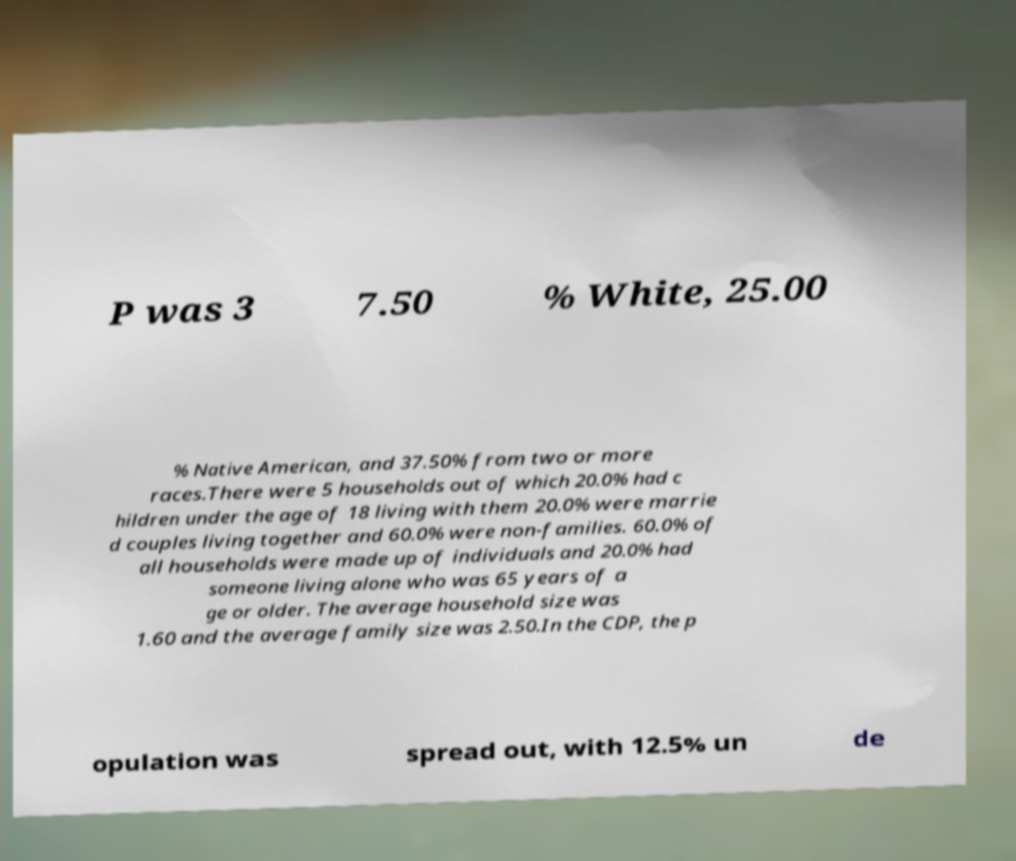Can you read and provide the text displayed in the image?This photo seems to have some interesting text. Can you extract and type it out for me? P was 3 7.50 % White, 25.00 % Native American, and 37.50% from two or more races.There were 5 households out of which 20.0% had c hildren under the age of 18 living with them 20.0% were marrie d couples living together and 60.0% were non-families. 60.0% of all households were made up of individuals and 20.0% had someone living alone who was 65 years of a ge or older. The average household size was 1.60 and the average family size was 2.50.In the CDP, the p opulation was spread out, with 12.5% un de 